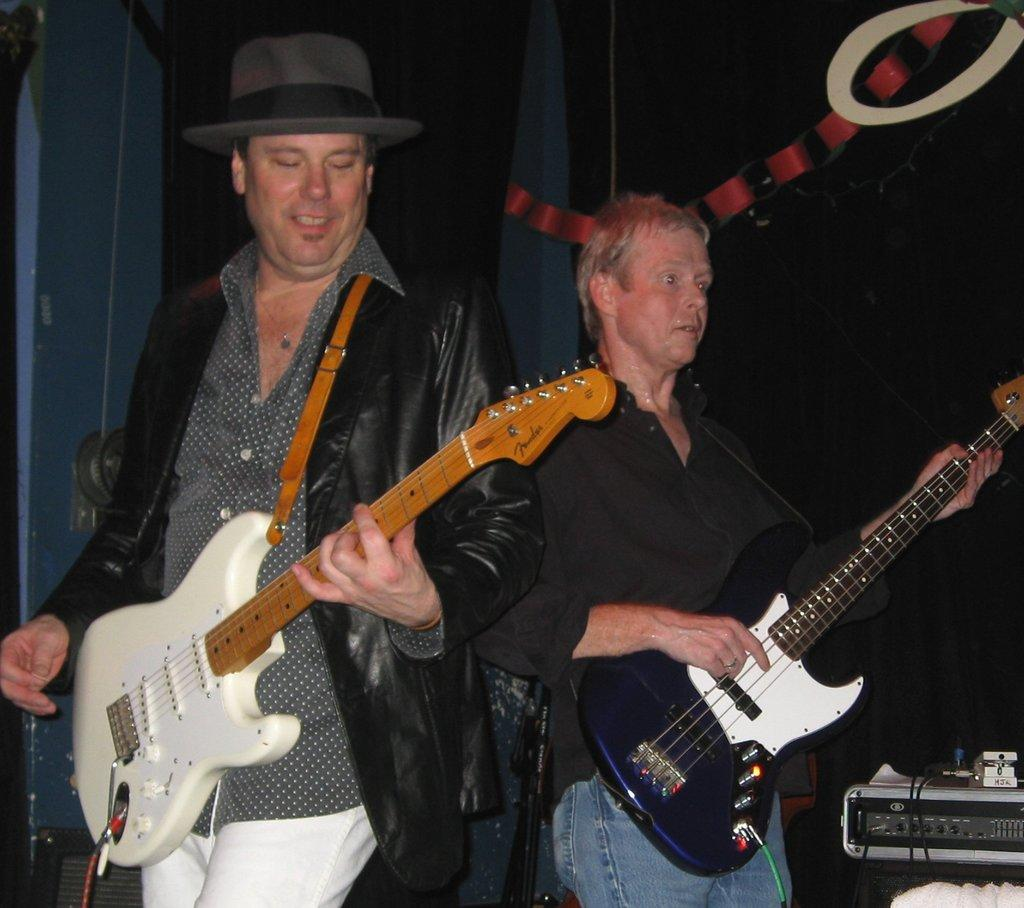How many persons are present in the image? There are two persons in the image. What are the two persons doing in the image? The two persons are playing guitar. What is the color of the background in the image? The background of the image is black in color. What is the reason for the lead guitarist to play the guitar in the image? There is no specific reason mentioned for the lead guitarist to play the guitar in the image, as the facts provided do not mention any context or situation. What is the history behind the black background in the image? There is no information provided about the history behind the black background in the image. 